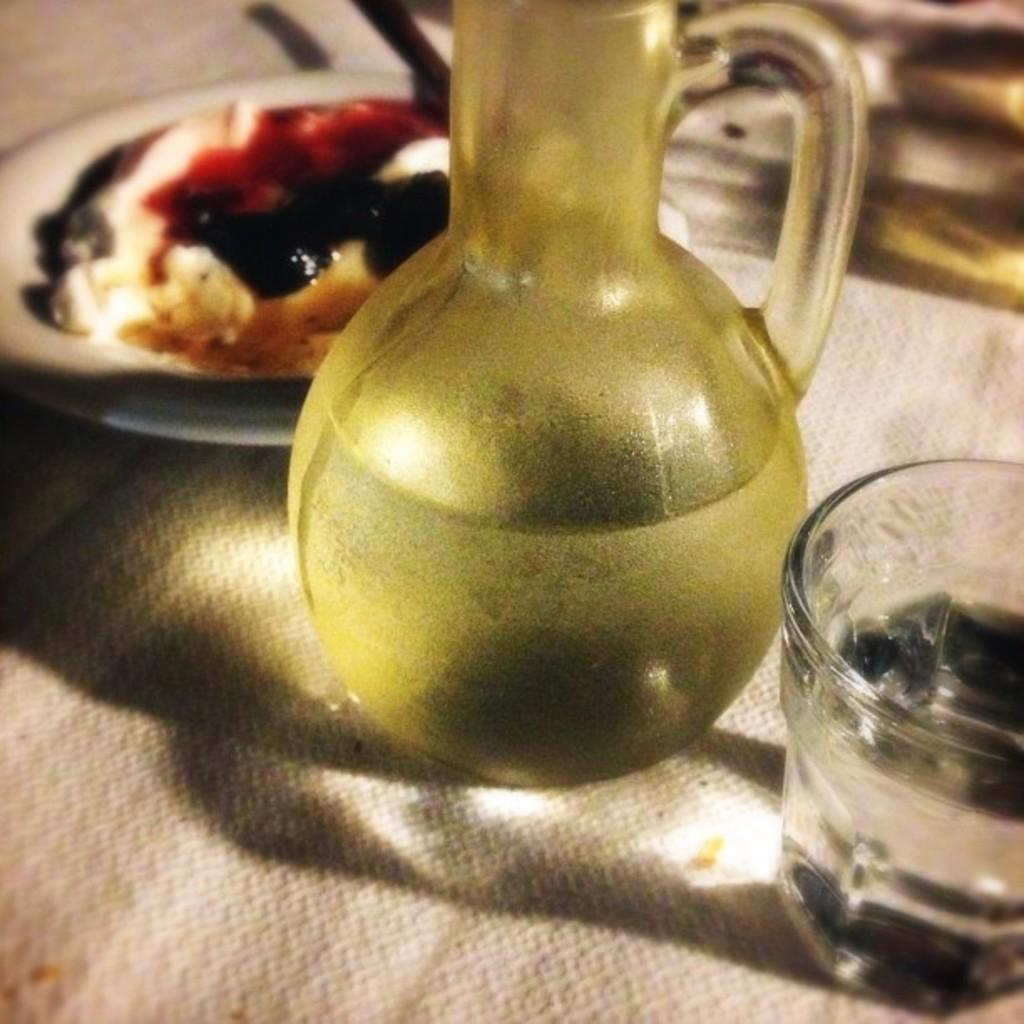What is the liquid-holding container visible in the image? There is a jug of water in the image. What is the smaller liquid-holding container in the image? There is a glass of water in the image. Where are the jug and glass of water located? Both the jug and glass of water are on a table. What else can be seen on the table in the image? There is a plate with food in the image. What type of bell can be heard ringing in the image? There is no bell present in the image, and therefore no sound can be heard. 